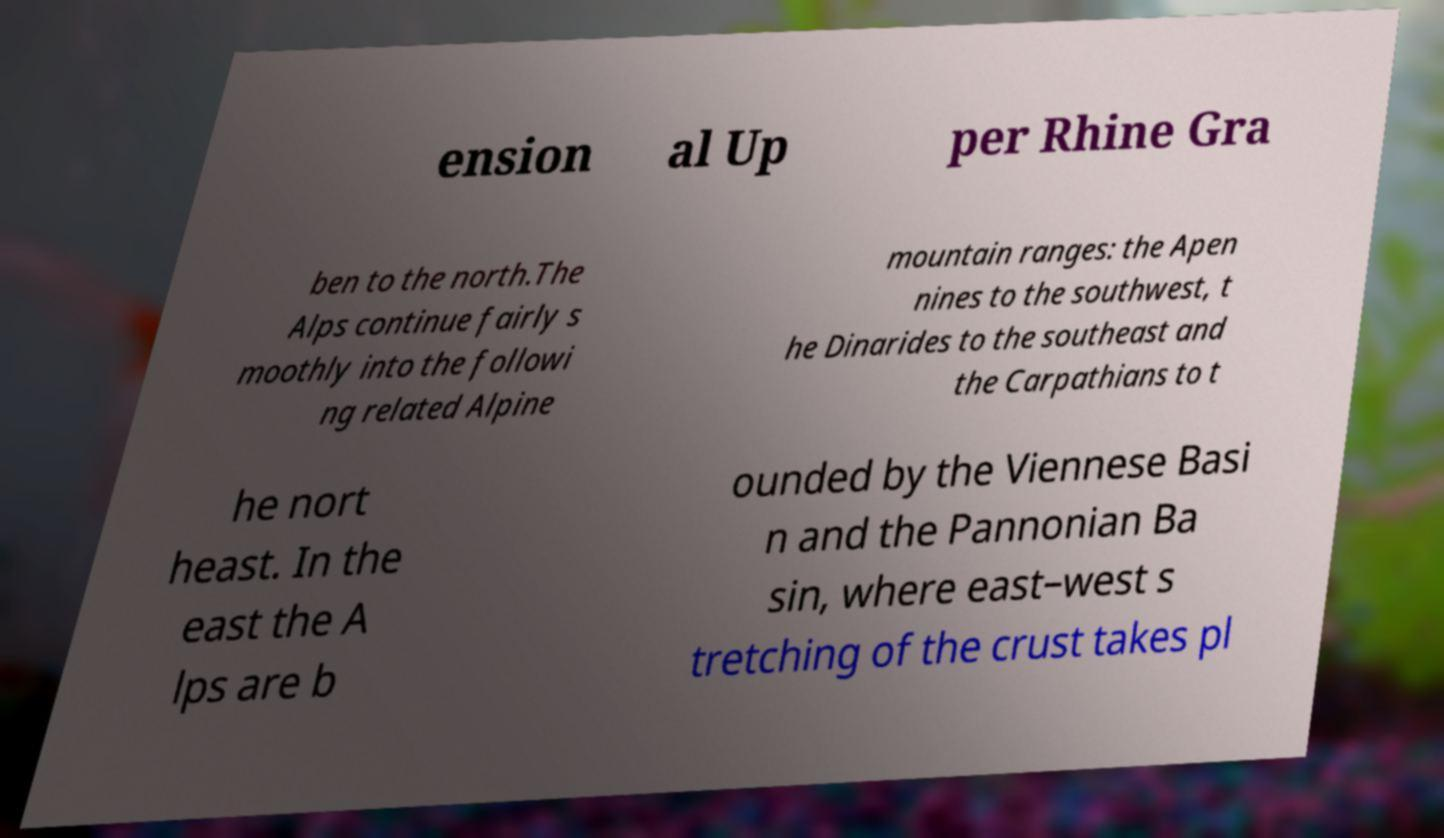There's text embedded in this image that I need extracted. Can you transcribe it verbatim? ension al Up per Rhine Gra ben to the north.The Alps continue fairly s moothly into the followi ng related Alpine mountain ranges: the Apen nines to the southwest, t he Dinarides to the southeast and the Carpathians to t he nort heast. In the east the A lps are b ounded by the Viennese Basi n and the Pannonian Ba sin, where east–west s tretching of the crust takes pl 